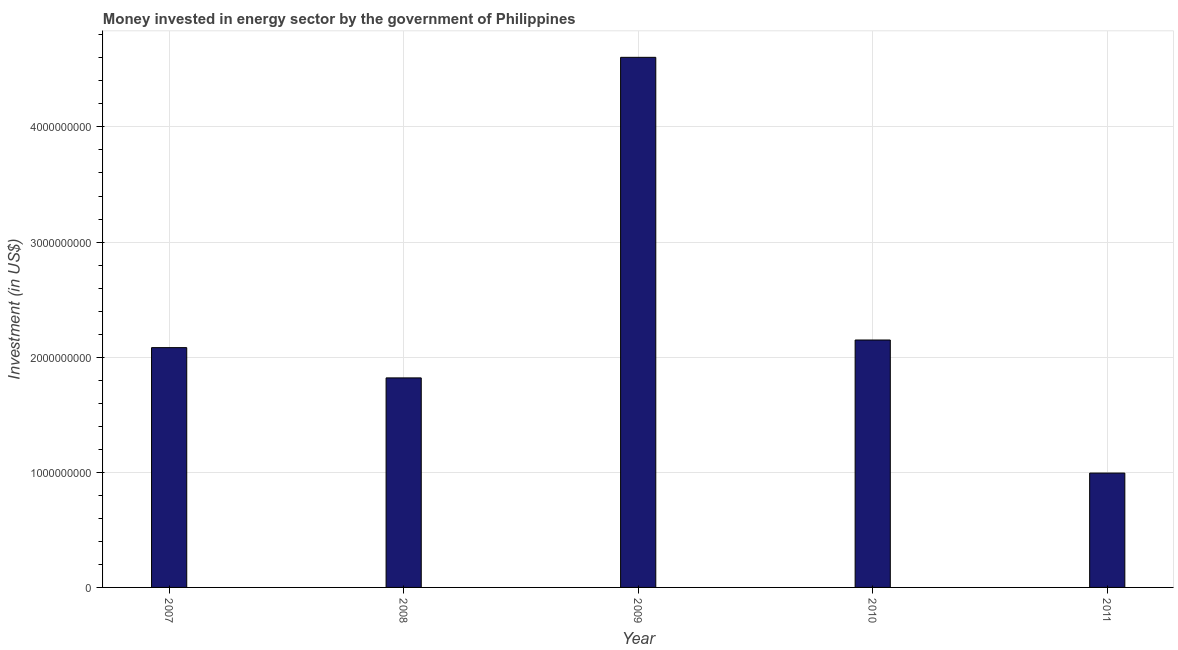Does the graph contain any zero values?
Make the answer very short. No. Does the graph contain grids?
Give a very brief answer. Yes. What is the title of the graph?
Your answer should be compact. Money invested in energy sector by the government of Philippines. What is the label or title of the Y-axis?
Ensure brevity in your answer.  Investment (in US$). What is the investment in energy in 2008?
Make the answer very short. 1.82e+09. Across all years, what is the maximum investment in energy?
Your answer should be compact. 4.60e+09. Across all years, what is the minimum investment in energy?
Ensure brevity in your answer.  9.93e+08. In which year was the investment in energy maximum?
Make the answer very short. 2009. In which year was the investment in energy minimum?
Your response must be concise. 2011. What is the sum of the investment in energy?
Ensure brevity in your answer.  1.17e+1. What is the difference between the investment in energy in 2007 and 2011?
Keep it short and to the point. 1.09e+09. What is the average investment in energy per year?
Your answer should be compact. 2.33e+09. What is the median investment in energy?
Offer a terse response. 2.08e+09. In how many years, is the investment in energy greater than 3800000000 US$?
Ensure brevity in your answer.  1. What is the ratio of the investment in energy in 2007 to that in 2011?
Your response must be concise. 2.1. What is the difference between the highest and the second highest investment in energy?
Provide a short and direct response. 2.46e+09. What is the difference between the highest and the lowest investment in energy?
Give a very brief answer. 3.61e+09. In how many years, is the investment in energy greater than the average investment in energy taken over all years?
Provide a succinct answer. 1. Are all the bars in the graph horizontal?
Offer a terse response. No. How many years are there in the graph?
Your answer should be compact. 5. What is the difference between two consecutive major ticks on the Y-axis?
Your answer should be compact. 1.00e+09. Are the values on the major ticks of Y-axis written in scientific E-notation?
Give a very brief answer. No. What is the Investment (in US$) in 2007?
Your response must be concise. 2.08e+09. What is the Investment (in US$) of 2008?
Make the answer very short. 1.82e+09. What is the Investment (in US$) in 2009?
Ensure brevity in your answer.  4.60e+09. What is the Investment (in US$) of 2010?
Your answer should be very brief. 2.15e+09. What is the Investment (in US$) in 2011?
Give a very brief answer. 9.93e+08. What is the difference between the Investment (in US$) in 2007 and 2008?
Your response must be concise. 2.63e+08. What is the difference between the Investment (in US$) in 2007 and 2009?
Your response must be concise. -2.52e+09. What is the difference between the Investment (in US$) in 2007 and 2010?
Offer a terse response. -6.62e+07. What is the difference between the Investment (in US$) in 2007 and 2011?
Provide a succinct answer. 1.09e+09. What is the difference between the Investment (in US$) in 2008 and 2009?
Ensure brevity in your answer.  -2.78e+09. What is the difference between the Investment (in US$) in 2008 and 2010?
Keep it short and to the point. -3.29e+08. What is the difference between the Investment (in US$) in 2008 and 2011?
Your response must be concise. 8.27e+08. What is the difference between the Investment (in US$) in 2009 and 2010?
Provide a succinct answer. 2.46e+09. What is the difference between the Investment (in US$) in 2009 and 2011?
Provide a succinct answer. 3.61e+09. What is the difference between the Investment (in US$) in 2010 and 2011?
Give a very brief answer. 1.16e+09. What is the ratio of the Investment (in US$) in 2007 to that in 2008?
Offer a very short reply. 1.15. What is the ratio of the Investment (in US$) in 2007 to that in 2009?
Give a very brief answer. 0.45. What is the ratio of the Investment (in US$) in 2007 to that in 2010?
Your answer should be very brief. 0.97. What is the ratio of the Investment (in US$) in 2007 to that in 2011?
Ensure brevity in your answer.  2.1. What is the ratio of the Investment (in US$) in 2008 to that in 2009?
Ensure brevity in your answer.  0.4. What is the ratio of the Investment (in US$) in 2008 to that in 2010?
Give a very brief answer. 0.85. What is the ratio of the Investment (in US$) in 2008 to that in 2011?
Make the answer very short. 1.83. What is the ratio of the Investment (in US$) in 2009 to that in 2010?
Your response must be concise. 2.14. What is the ratio of the Investment (in US$) in 2009 to that in 2011?
Give a very brief answer. 4.63. What is the ratio of the Investment (in US$) in 2010 to that in 2011?
Give a very brief answer. 2.16. 